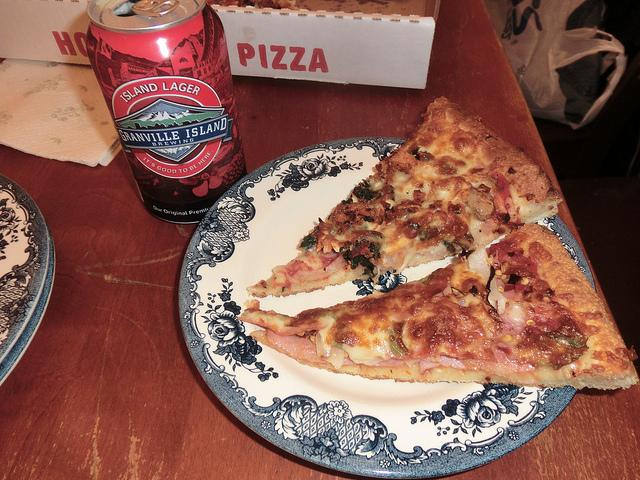What kind of beverage is being enjoyed with the pizza? Please explain your reasoning. beer. Lager is a type of alcohol, and beer is sometimes packaged in aluminum cans. 